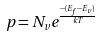<formula> <loc_0><loc_0><loc_500><loc_500>p = N _ { v } e ^ { \frac { - ( E _ { f } - E _ { v } ) } { k T } }</formula> 